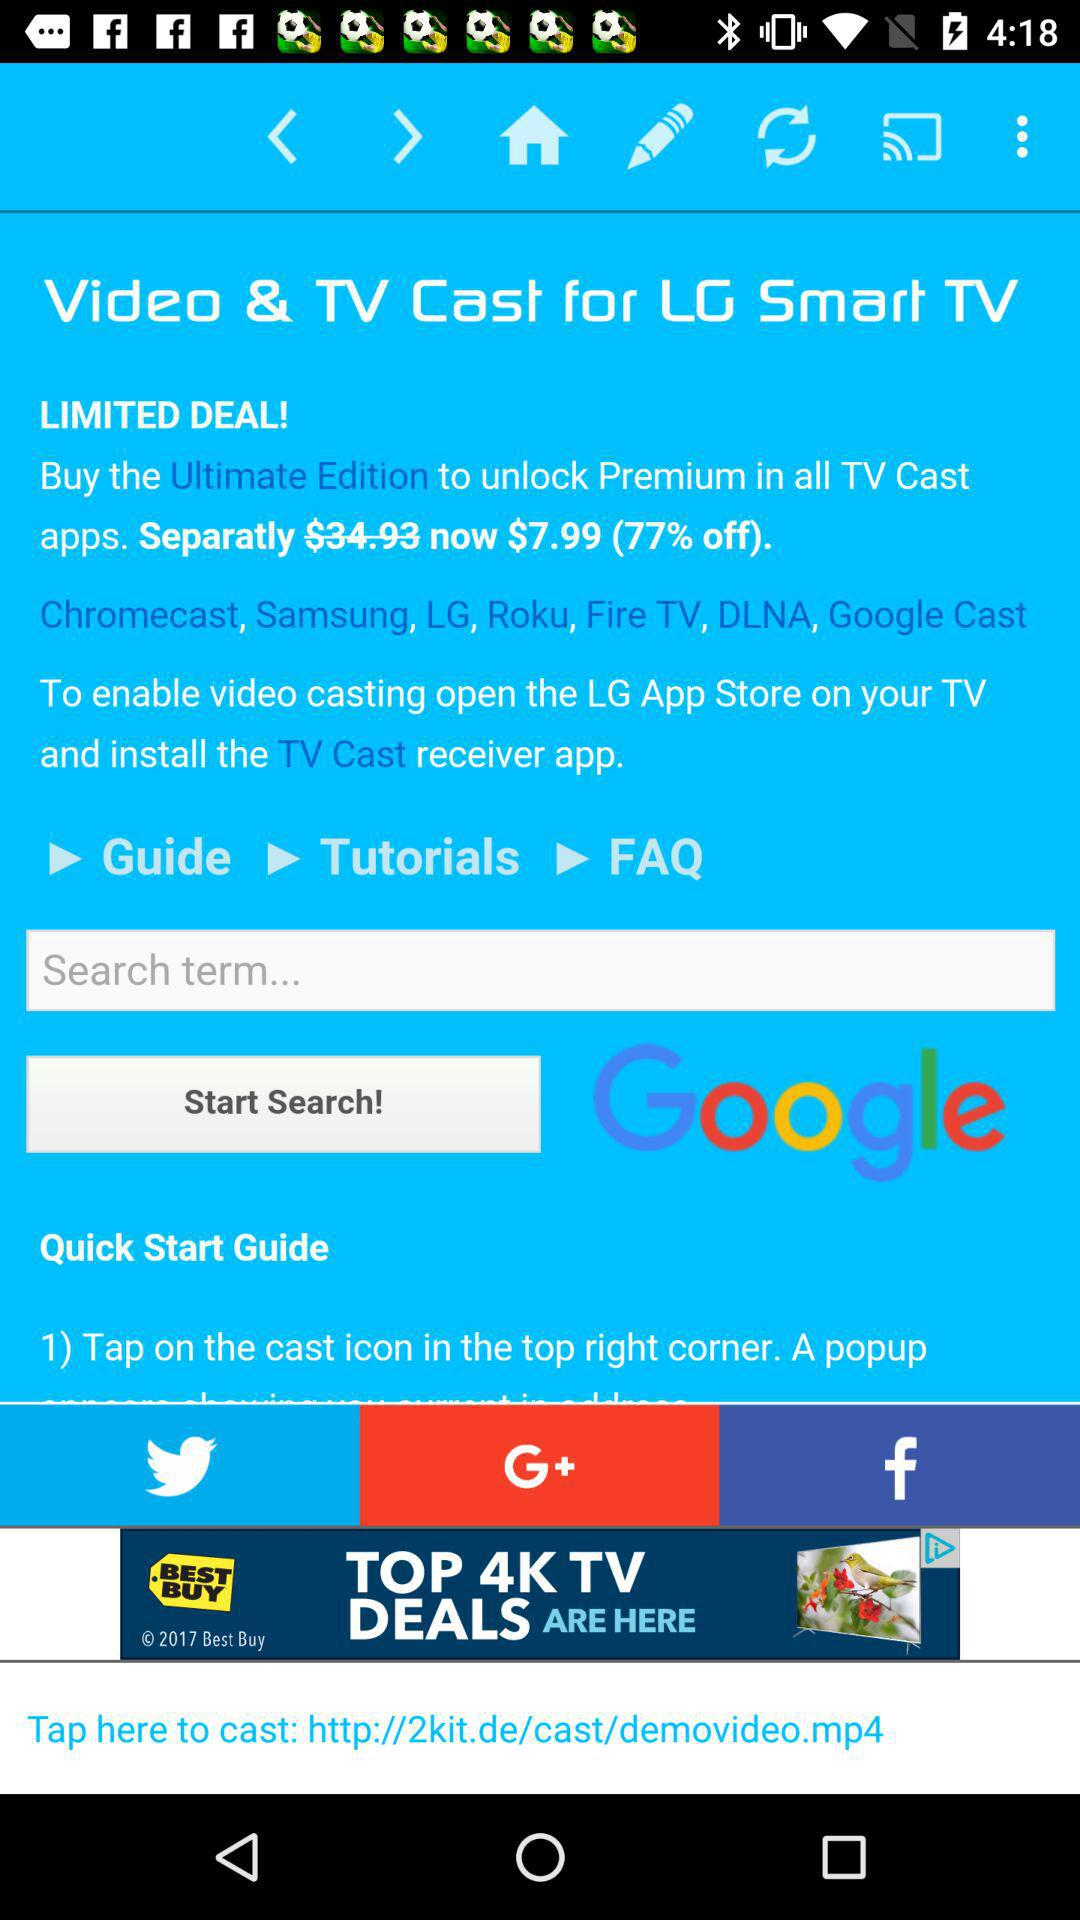What is the actual price? The actual price is $34.93. 